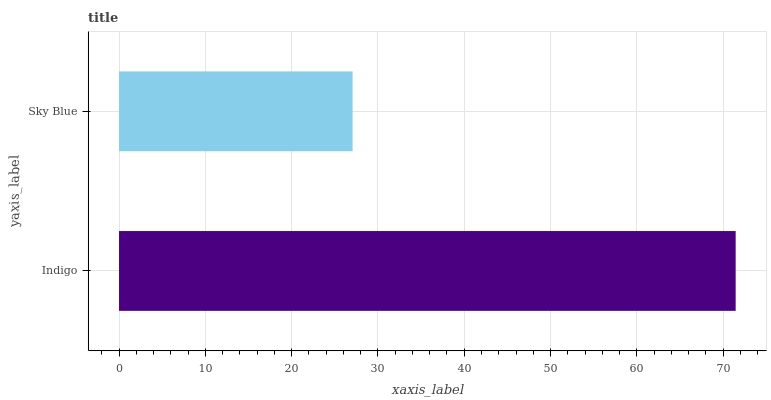Is Sky Blue the minimum?
Answer yes or no. Yes. Is Indigo the maximum?
Answer yes or no. Yes. Is Sky Blue the maximum?
Answer yes or no. No. Is Indigo greater than Sky Blue?
Answer yes or no. Yes. Is Sky Blue less than Indigo?
Answer yes or no. Yes. Is Sky Blue greater than Indigo?
Answer yes or no. No. Is Indigo less than Sky Blue?
Answer yes or no. No. Is Indigo the high median?
Answer yes or no. Yes. Is Sky Blue the low median?
Answer yes or no. Yes. Is Sky Blue the high median?
Answer yes or no. No. Is Indigo the low median?
Answer yes or no. No. 